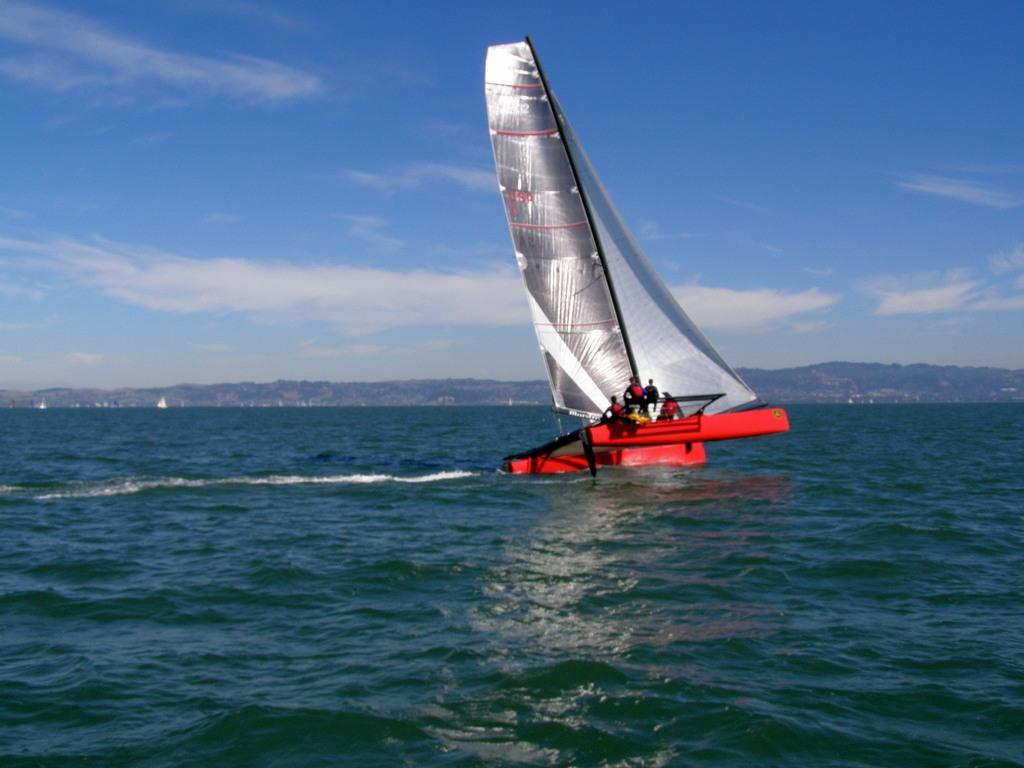What is the main subject of the image? The main subject of the image is a boat. Where is the boat located? The boat is on the water. What can be seen in the background of the image? Hills and the sky are visible in the background of the image. How many worms can be seen crawling on the desk in the image? There are no worms or desks present in the image; it features a boat on the water with hills and the sky in the background. 